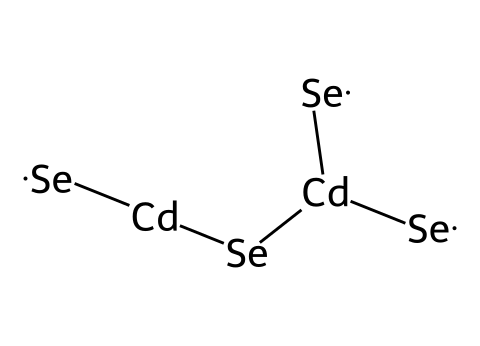What elements are present in this quantum dot structure? The SMILES representation indicates the presence of cadmium (Cd) and selenium (Se) atoms, as both elements are explicitly mentioned.
Answer: cadmium and selenium How many selenium atoms are in this quantum dot? By counting the occurrences of the selenium symbol (Se) in the SMILES representation, there are four selenium atoms present in total.
Answer: four What is the coordination number of cadmium in this structure? The cadmium atoms are each coordinated to three selenium atoms (as observed in the bonds shown to the Se atoms). Therefore, the coordination number for cadmium is three.
Answer: three How many cadmium atoms are present in this structure? The SMILES shows the symbol for cadmium (Cd) appearing twice, indicating that there are two cadmium atoms present in the quantum dot.
Answer: two What type of compound is formed by cadmium and selenium in this structure? Cadmium and selenium typically form a compound known as cadmium selenide, which is a type of semiconductor material commonly used in quantum dots.
Answer: semiconductor What determines the optical properties of the cadmium selenide quantum dots? The size and composition of the quantum dot, which include both the cadmium and selenium atoms as well as their ratios, influence the bandgap and, consequently, the optical properties of the material.
Answer: size and composition Why is cadmium selenide a popular choice for display technologies? Cadmium selenide is popular due to its efficient light-emitting properties and ability to produce vibrant colors, making it suitable for high-quality display applications.
Answer: efficient light-emitting properties 